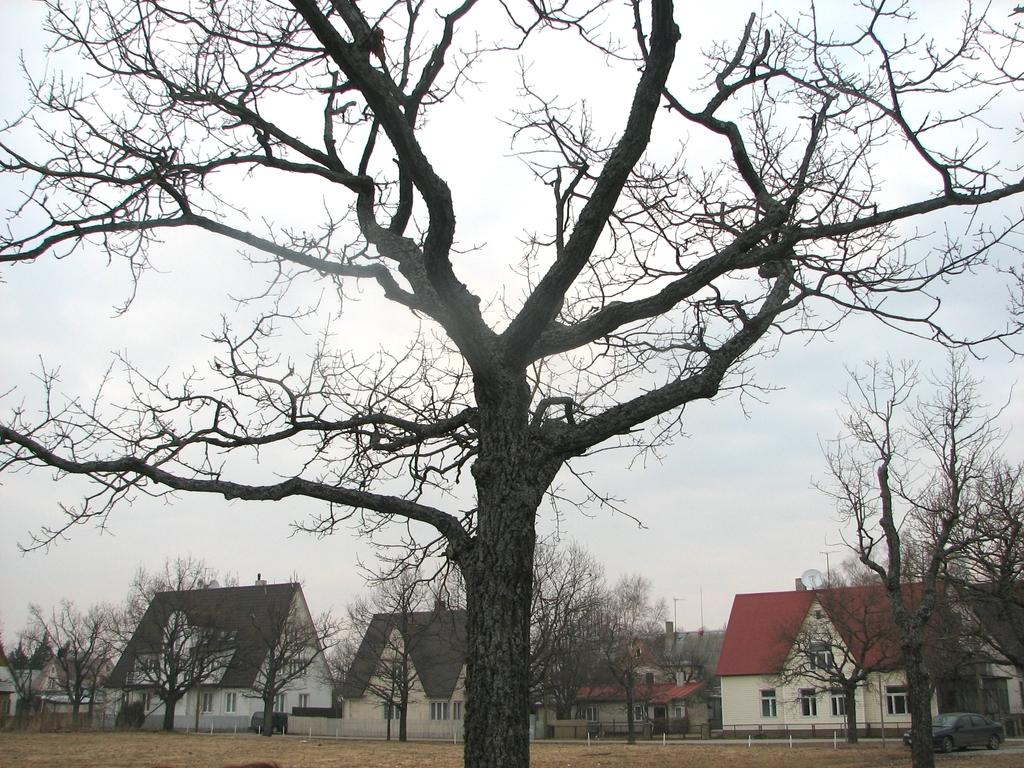What type of natural element is present in the image? There is a tree in the image. What can be seen in the background of the image? There are trees and buildings with windows in the background of the image. What is visible in the sky in the image? The sky is visible in the background of the image. What type of man-made object is present in the image? There is a car in the image. What month is it in the image? The month cannot be determined from the image, as there is no information provided about the time of year. 